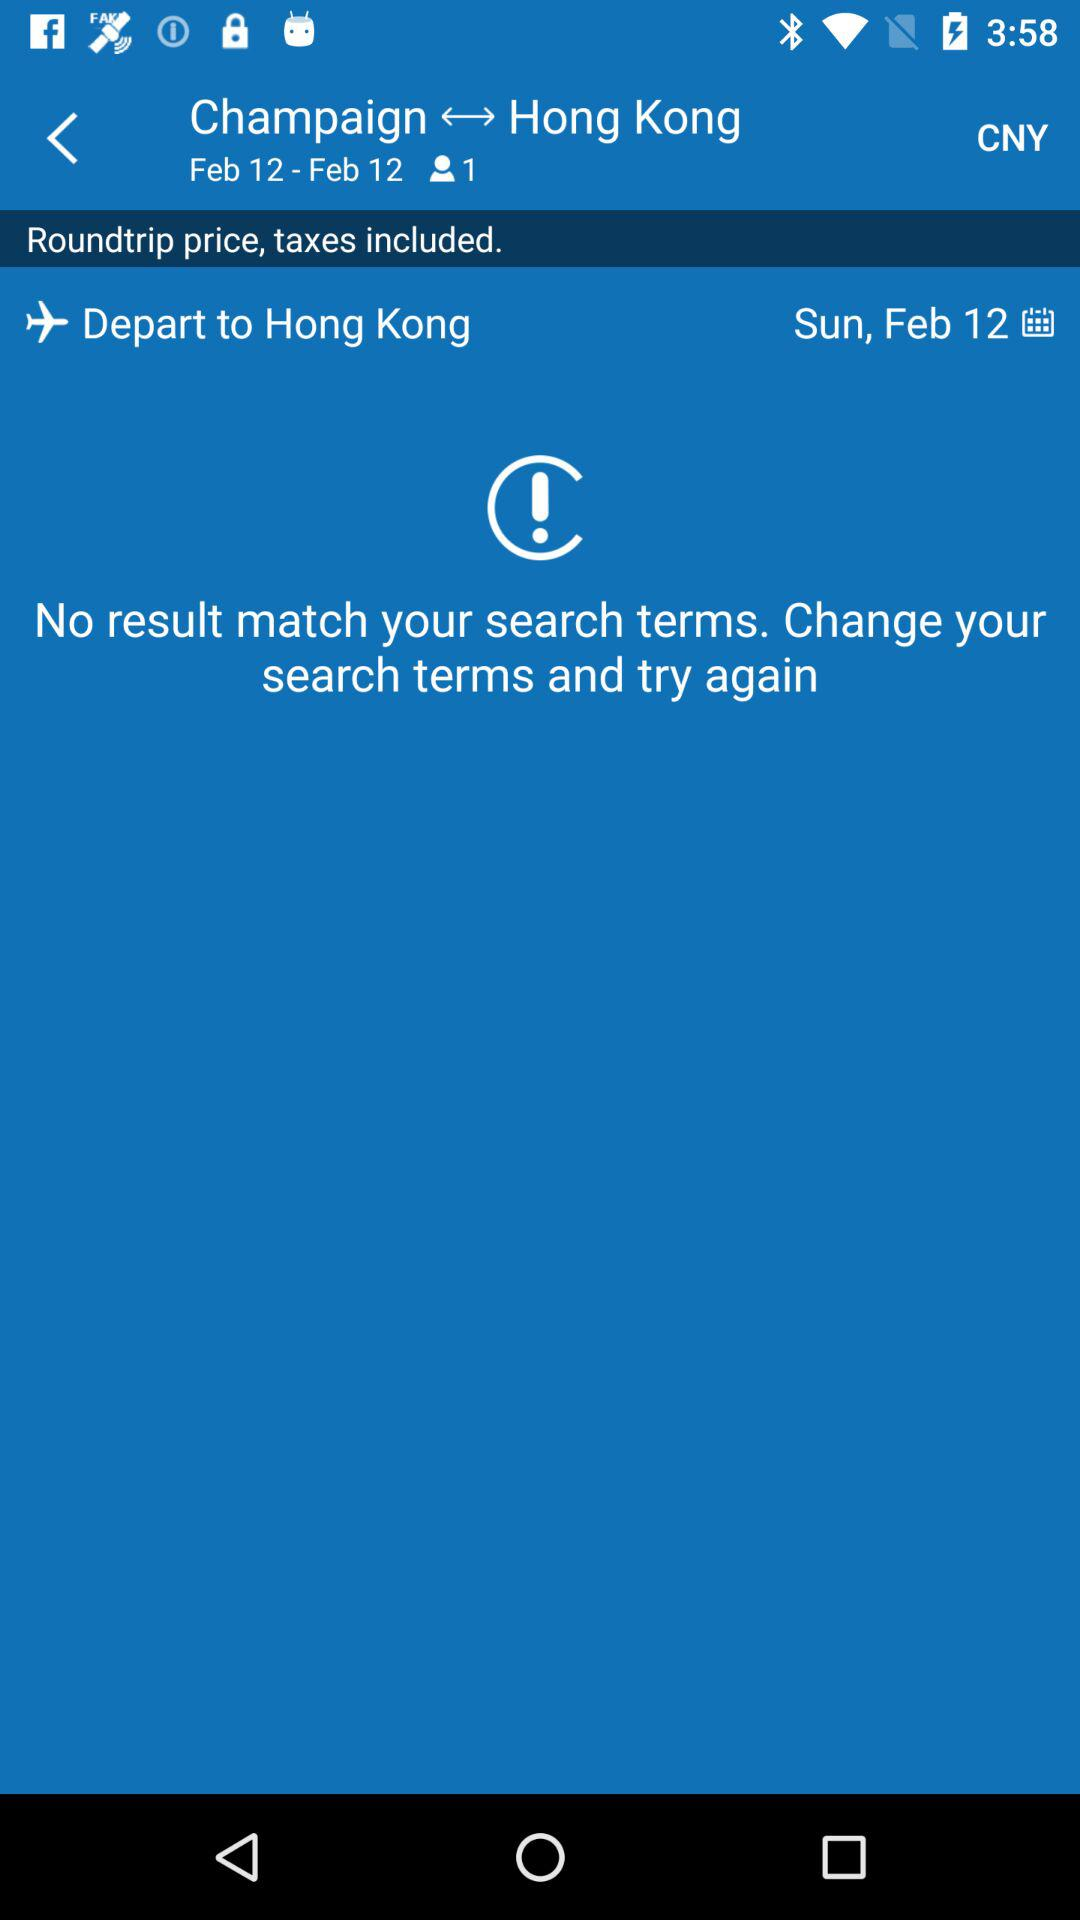How many people are in the selected travel party?
Answer the question using a single word or phrase. 1 